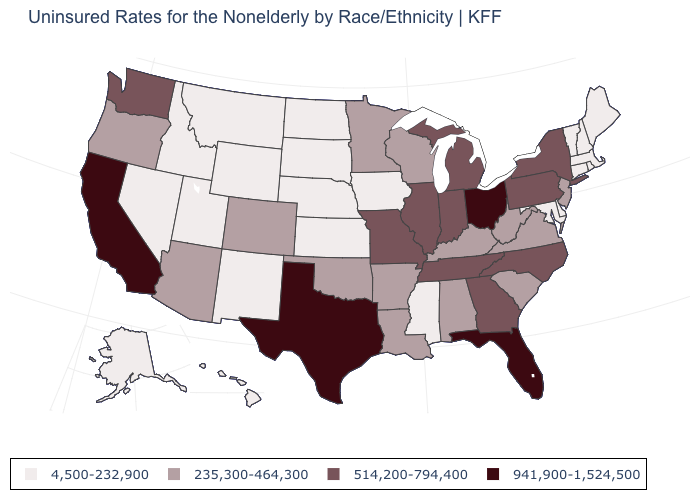What is the value of Oregon?
Answer briefly. 235,300-464,300. What is the value of Rhode Island?
Short answer required. 4,500-232,900. Is the legend a continuous bar?
Write a very short answer. No. Among the states that border Virginia , which have the highest value?
Write a very short answer. North Carolina, Tennessee. Name the states that have a value in the range 941,900-1,524,500?
Answer briefly. California, Florida, Ohio, Texas. What is the value of New York?
Keep it brief. 514,200-794,400. Name the states that have a value in the range 4,500-232,900?
Keep it brief. Alaska, Connecticut, Delaware, Hawaii, Idaho, Iowa, Kansas, Maine, Maryland, Massachusetts, Mississippi, Montana, Nebraska, Nevada, New Hampshire, New Mexico, North Dakota, Rhode Island, South Dakota, Utah, Vermont, Wyoming. What is the value of Oklahoma?
Short answer required. 235,300-464,300. Name the states that have a value in the range 235,300-464,300?
Be succinct. Alabama, Arizona, Arkansas, Colorado, Kentucky, Louisiana, Minnesota, New Jersey, Oklahoma, Oregon, South Carolina, Virginia, West Virginia, Wisconsin. What is the highest value in the MidWest ?
Be succinct. 941,900-1,524,500. How many symbols are there in the legend?
Keep it brief. 4. Is the legend a continuous bar?
Keep it brief. No. Does Arizona have a lower value than North Dakota?
Keep it brief. No. Does Connecticut have the lowest value in the USA?
Keep it brief. Yes. What is the value of Pennsylvania?
Write a very short answer. 514,200-794,400. 